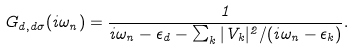<formula> <loc_0><loc_0><loc_500><loc_500>G _ { d , d \sigma } ( i \omega _ { n } ) = \frac { 1 } { i \omega _ { n } - \epsilon _ { d } - \sum _ { k } | V _ { k } | ^ { 2 } / ( i \omega _ { n } - \epsilon _ { k } ) } .</formula> 